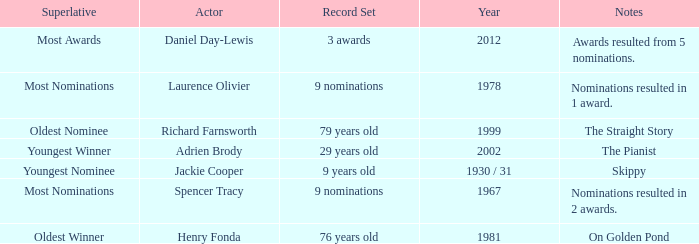Parse the full table. {'header': ['Superlative', 'Actor', 'Record Set', 'Year', 'Notes'], 'rows': [['Most Awards', 'Daniel Day-Lewis', '3 awards', '2012', 'Awards resulted from 5 nominations.'], ['Most Nominations', 'Laurence Olivier', '9 nominations', '1978', 'Nominations resulted in 1 award.'], ['Oldest Nominee', 'Richard Farnsworth', '79 years old', '1999', 'The Straight Story'], ['Youngest Winner', 'Adrien Brody', '29 years old', '2002', 'The Pianist'], ['Youngest Nominee', 'Jackie Cooper', '9 years old', '1930 / 31', 'Skippy'], ['Most Nominations', 'Spencer Tracy', '9 nominations', '1967', 'Nominations resulted in 2 awards.'], ['Oldest Winner', 'Henry Fonda', '76 years old', '1981', 'On Golden Pond']]} What are the notes in 1981? On Golden Pond. 